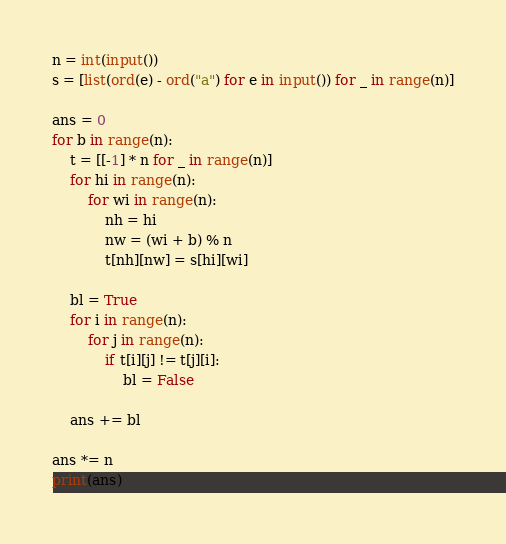Convert code to text. <code><loc_0><loc_0><loc_500><loc_500><_Python_>n = int(input())
s = [list(ord(e) - ord("a") for e in input()) for _ in range(n)]

ans = 0
for b in range(n):
    t = [[-1] * n for _ in range(n)]
    for hi in range(n):
        for wi in range(n):
            nh = hi
            nw = (wi + b) % n
            t[nh][nw] = s[hi][wi]

    bl = True
    for i in range(n):
        for j in range(n):
            if t[i][j] != t[j][i]:
                bl = False

    ans += bl

ans *= n
print(ans)
</code> 